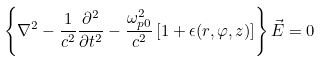<formula> <loc_0><loc_0><loc_500><loc_500>\left \{ \nabla ^ { 2 } - \frac { 1 } { c ^ { 2 } } \frac { \partial ^ { 2 } } { \partial t ^ { 2 } } - \frac { \omega _ { p 0 } ^ { 2 } } { c ^ { 2 } } \left [ 1 + \epsilon ( r , \varphi , z ) \right ] \right \} \vec { E } = 0</formula> 